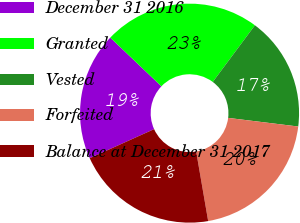Convert chart to OTSL. <chart><loc_0><loc_0><loc_500><loc_500><pie_chart><fcel>December 31 2016<fcel>Granted<fcel>Vested<fcel>Forfeited<fcel>Balance at December 31 2017<nl><fcel>18.86%<fcel>23.06%<fcel>16.77%<fcel>20.33%<fcel>20.97%<nl></chart> 